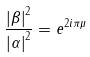Convert formula to latex. <formula><loc_0><loc_0><loc_500><loc_500>\frac { \left | \beta \right | ^ { 2 } } { \left | \alpha \right | ^ { 2 } } = e ^ { 2 i \pi \mu }</formula> 